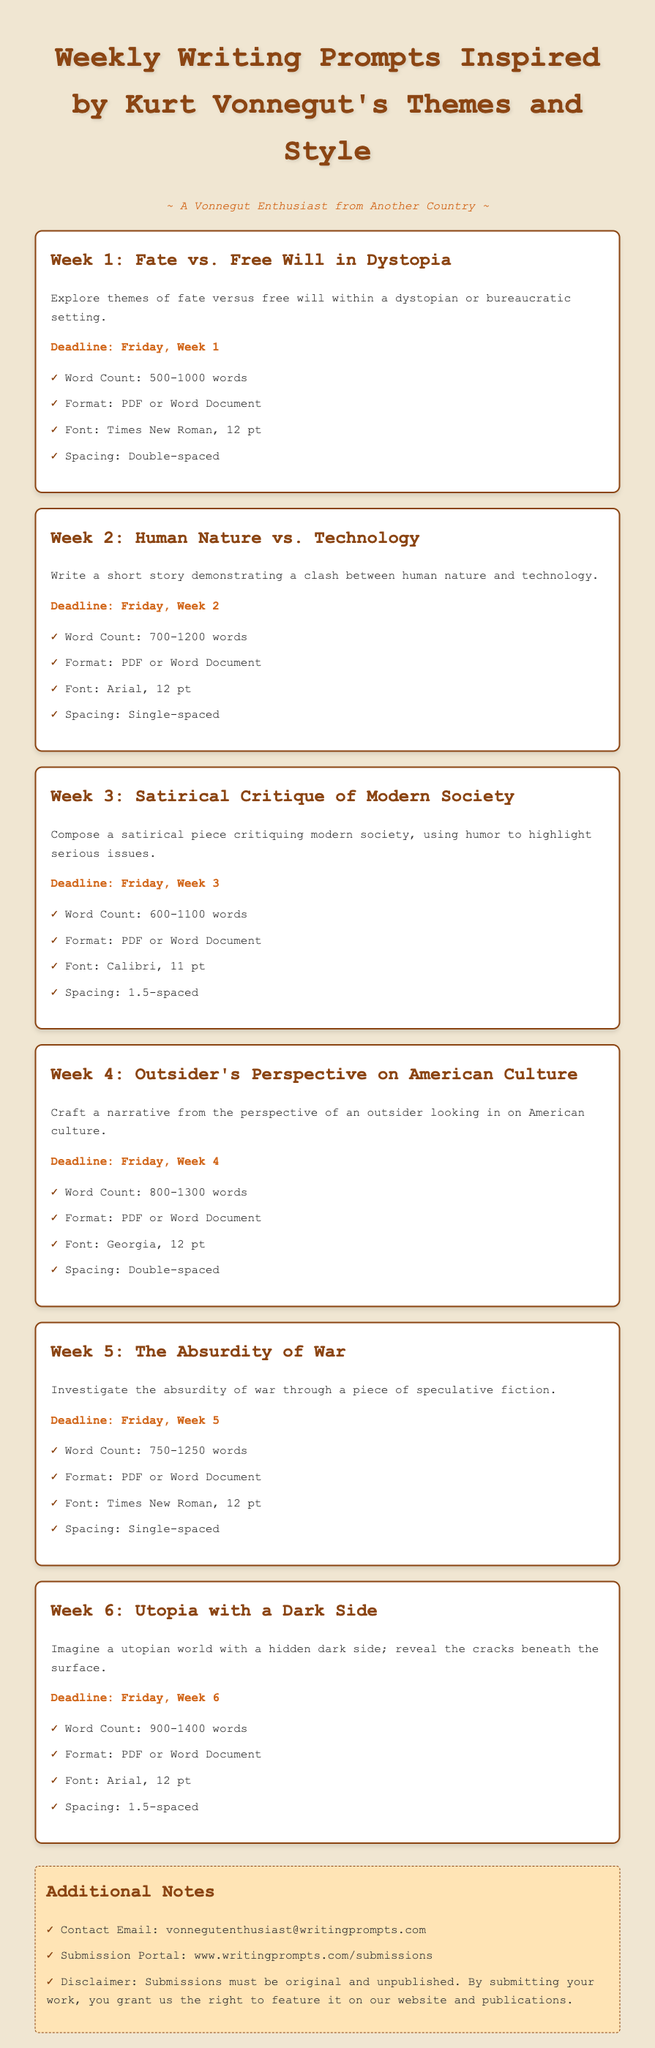What is the focus of Week 1's prompt? The prompt for Week 1 explores themes of fate versus free will within a dystopian or bureaucratic setting.
Answer: Fate vs. Free Will in Dystopia How many words are required for Week 2's submission? Week 2's prompt specifies a word count of 700 to 1200 words.
Answer: 700-1200 words What font style is required for Week 3? The document states that submissions for Week 3 should use Calibri, 11 pt font.
Answer: Calibri, 11 pt When is the submission deadline for Week 4? Week 4's deadline is set for Friday, Week 4.
Answer: Friday, Week 4 What overarching theme is explored in Week 5? The prompt for Week 5 investigates the absurdity of war through speculative fiction.
Answer: The Absurdity of War What is the submission format for all prompts? Each prompt requires submissions in either PDF or Word Document format.
Answer: PDF or Word Document What additional notes are provided regarding submissions? The additional notes include contact email, submission portal, and a disclaimer about original work.
Answer: Original and unpublished What spacing is required for Week 6 submissions? Week 6 specifies single-spaced submissions.
Answer: Single-spaced 